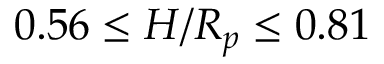<formula> <loc_0><loc_0><loc_500><loc_500>0 . 5 6 \leq H / R _ { p } \leq 0 . 8 1</formula> 